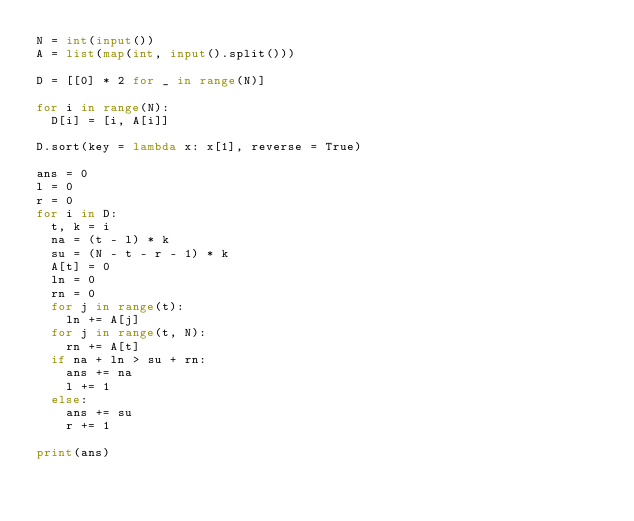Convert code to text. <code><loc_0><loc_0><loc_500><loc_500><_Python_>N = int(input())
A = list(map(int, input().split()))

D = [[0] * 2 for _ in range(N)]

for i in range(N):
  D[i] = [i, A[i]]

D.sort(key = lambda x: x[1], reverse = True)

ans = 0
l = 0
r = 0
for i in D:
  t, k = i
  na = (t - l) * k
  su = (N - t - r - 1) * k
  A[t] = 0
  ln = 0
  rn = 0
  for j in range(t):
    ln += A[j]
  for j in range(t, N):
    rn += A[t]
  if na + ln > su + rn:
    ans += na
    l += 1
  else:
    ans += su
    r += 1

print(ans)</code> 